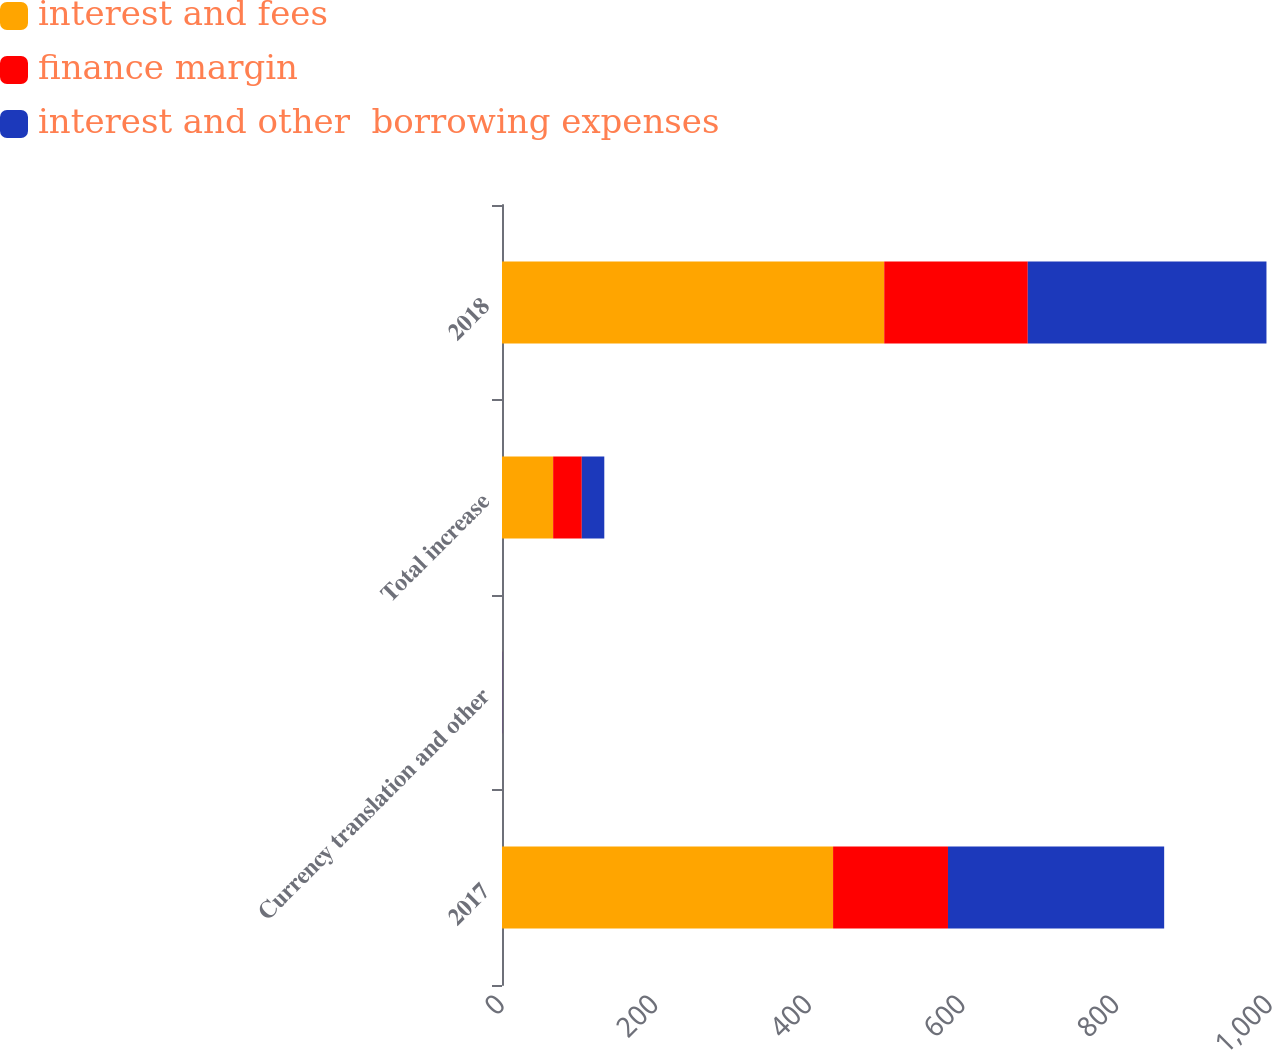Convert chart. <chart><loc_0><loc_0><loc_500><loc_500><stacked_bar_chart><ecel><fcel>2017<fcel>Currency translation and other<fcel>Total increase<fcel>2018<nl><fcel>interest and fees<fcel>431.1<fcel>0.5<fcel>66.6<fcel>497.7<nl><fcel>finance margin<fcel>149.6<fcel>0.1<fcel>37.3<fcel>186.9<nl><fcel>interest and other  borrowing expenses<fcel>281.5<fcel>0.6<fcel>29.3<fcel>310.8<nl></chart> 